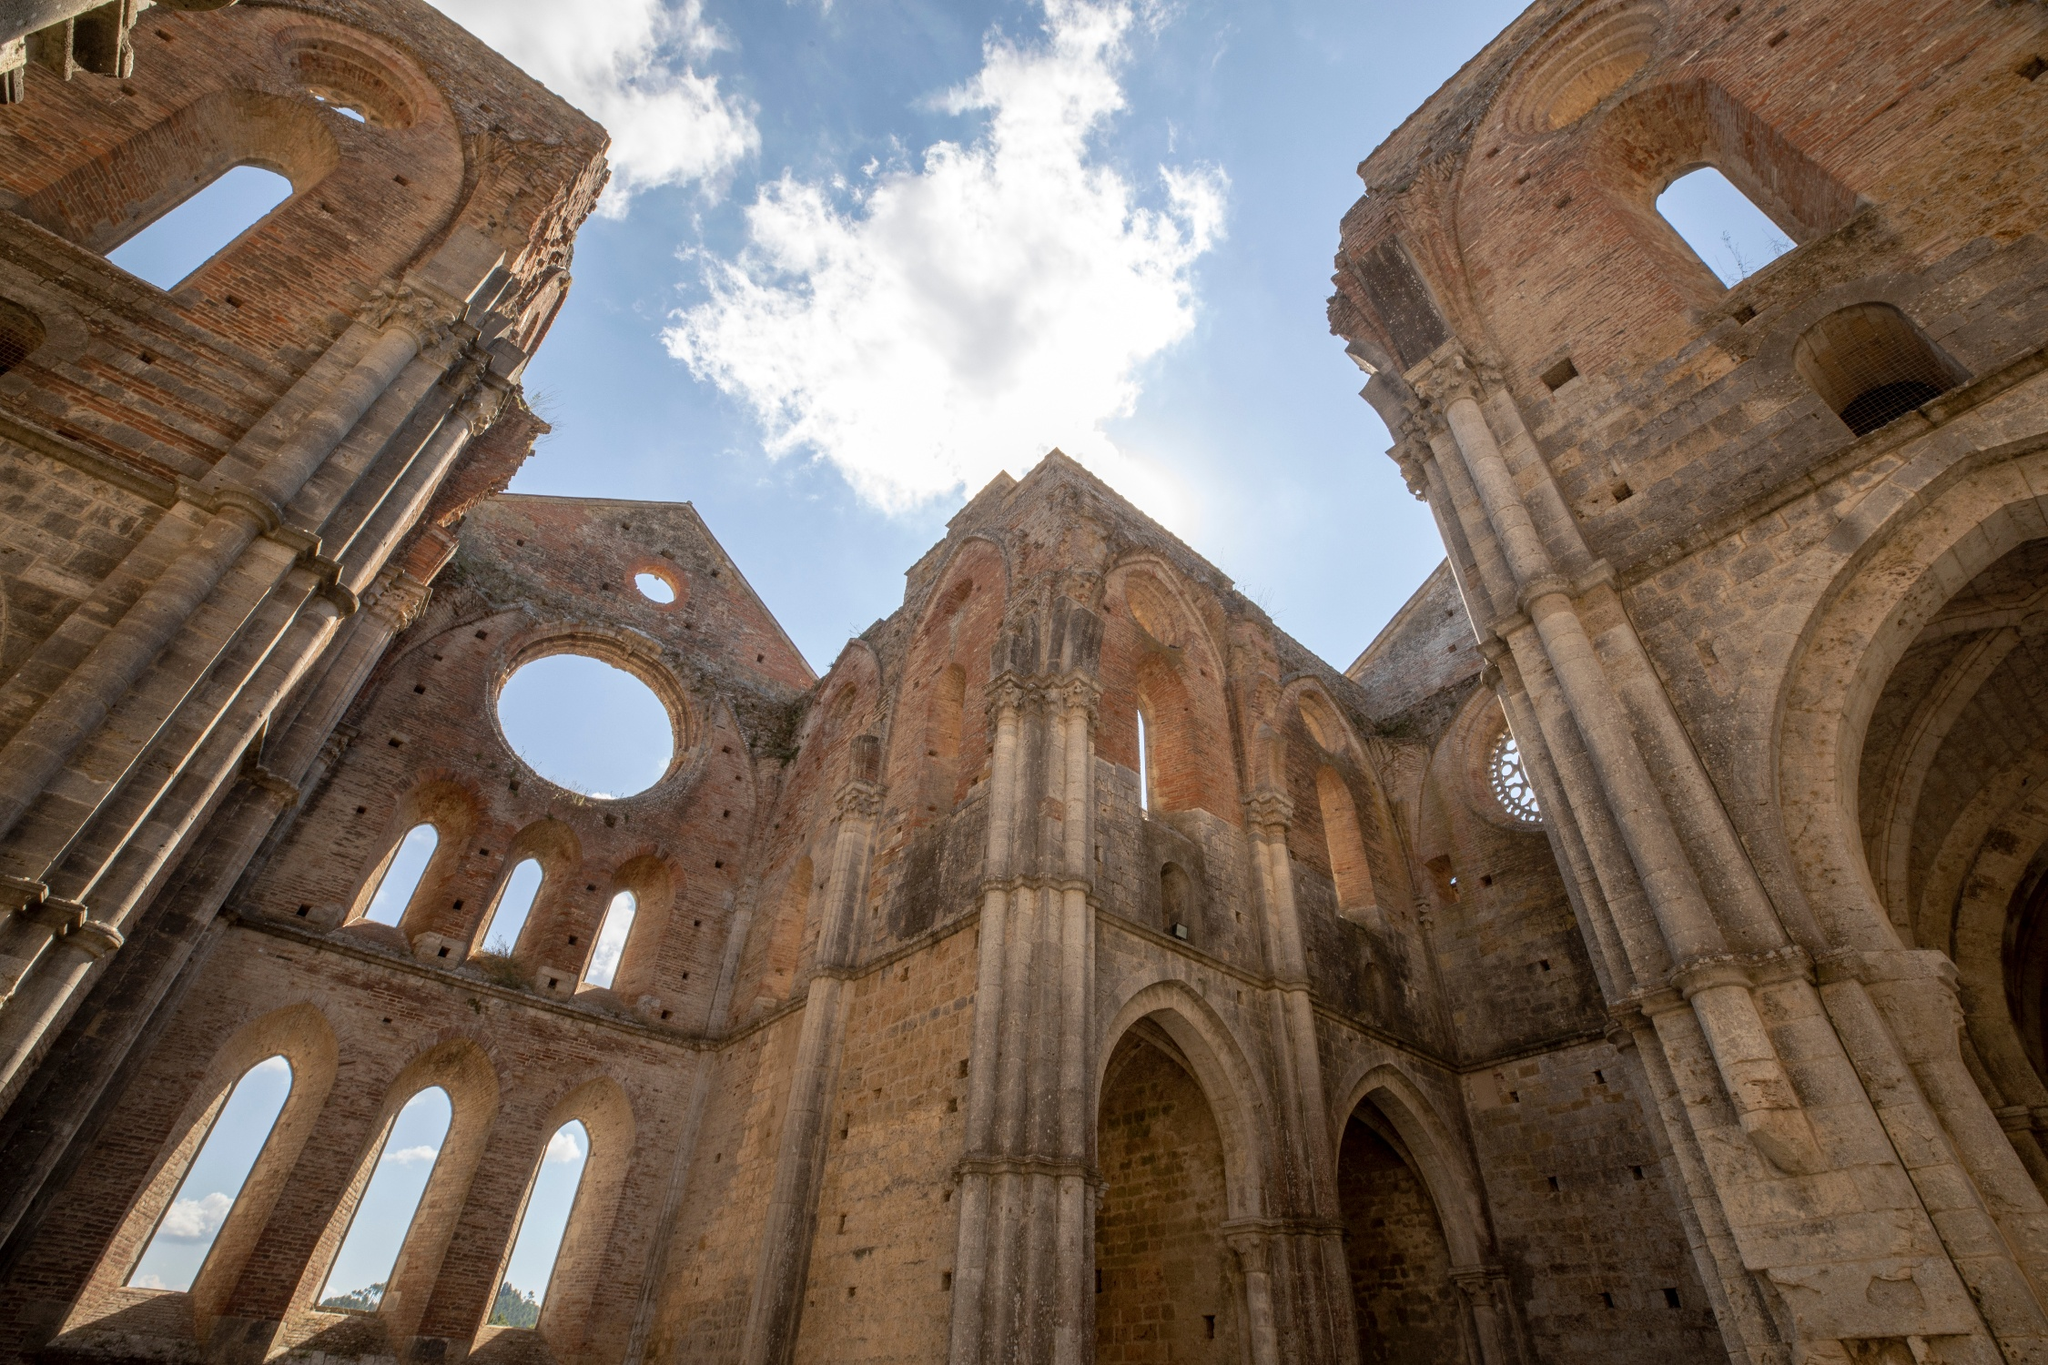If these ruins could talk, what stories would they tell? If the ancient stones of these ruins could talk, they would recount tales of reverence and ruin, of hopes and heartaches that have touched their towering arches. They would speak of the countless souls who once gathered within these now-empty halls, their prayers and hymns echoing through the centuries. They would remember the grand processions and solemn vows taken at the altar, now crumbled and quiet. They would tell of the great storm that brought down the mighty roof, and the wars that saw these walls witness both refuge and destruction.

The stones would reminisce about the artisans who, with delicate hands, etched their undying faith into every intricate carving and the villagers who sought solace within these walls during turbulent times. They would recount the whispers of lovers who stole secret moments away from prying eyes, and the innocent laughter of children, now long grown and gone.

These ruins, once the heart of a thriving community, now stand as a silent testament to resilience. They hold the echoes of the past, a reminder of the human spirit’s enduring strength and the relentless march of time that spares nothing in its path. Consider a post-apocalyptic future where these ruins are rediscovered. Write a short story about that. In the year 3025, Earth was a vastly different place, a planet slowly healing from centuries of human folly. Nature had reclaimed vast stretches of the old world, and new societies were forming, grounded in harmony and respect for the planet. Amidst this transformation, a small expedition group stumbled upon the forgotten ruins of an ancient cathedral, hidden deep within an overgrown forest.

The group, led by Lyra, an intrepid archaeologist, and her team of historians, approached the imposing arches with a mix of awe and reverence. The ruins, though weathered and partially crumbled, exuded an undeniable grandeur that transcended the ages. Vines and moss had weaved a verdant tapestry over the stone, and the open sky above created a natural dome that framed the remnants in a surreal light.

As they carefully navigated the sacred grounds, they found relics of a bygone era—tattered books of sacred texts, shattered stained glass with vibrant hues still visible, and stone engravings narrating tales of faith and perseverance. Lyra's heart raced as she uncovered a hidden chamber beneath the altar, untouched and waiting to share its secrets.

Inside the chamber, the group found a time capsule left by the ancient inhabitants. It contained artifacts of their daily life: a child's toy, a hand-written journal, and a small, well-preserved locket with a portrait of a woman and a man, likely once lost lovers separated by fate. The discovery stirred emotions among the group, a poignant reminder of the shared humanity that connected their distant past with their present.

Lyra and her team documented every find, knowing that these ruins held invaluable lessons. They resolved to preserve and protect this sacred site, ensuring that future generations could learn from the resilience and faith that had once defined these walls. As they departed, the cathedral’s stones basked in the warm glow of the setting sun, silently promising to hold their new stories for centuries to come. Can you hypothesize a realistic historical narrative for these ruins? Based on the architectural style and the materials used in the construction of these ruins, it is plausible to hypothesize that this was once a grand Gothic cathedral, constructed during the High Middle Ages, around the 12th to 14th centuries. The expansive arches, ribbed vaults, and pointed windows suggest a design meant to inspire awe and direct the gaze heavenwards, characteristic of Gothic architecture.

Historically, such cathedrals were central to both the religious and social lives of their communities. This cathedral likely served as a seat of the local bishopric, a place where significant religious ceremonies and events took place. It might have witnessed countless baptisms, weddings, and funerals, each leaving behind a trace of its human tapestry.

Its grand scale implies that it was a major pilgrimage site, drawing the faithful from surrounding regions. The rich histories etched into its walls suggest that skilled artisans spent decades embellishing the cathedral with elaborate stone carvings, stained glass windows depicting biblical scenes, and frescoes narrating the saints' lives.

The passage of time and the advent of wars, possibly the turbulence of the Reformation or local conflicts, could have led to its partial destruction. Natural disasters, such as earthquakes or fires, might also have contributed to its current state of disrepair. Over the centuries, as communities moved and the function of the cathedral diminished, it gradually fell into ruin, becoming the hauntingly beautiful relic we see today. How would nature interact with these ruins over time? Over time, nature would have a profound impact on the enduring ruins of the ancient cathedral, transforming the site into a symbiotic blend of human history and the natural world. Rain, wind, and varying temperatures would slowly erode the stonework, softening the once sharp edges and leading to the gradual disintegration of more delicate architectural features. Moss and lichen would take root in the damp crevices, spreading across the surfaces and adding a green patina to the weathered stone.

Climbing plants like ivy would envelop the columns and arches, their tendrils weaving through cracks and crevices, both stabilizing and further fracturing the structure. In time, entire sections might become cloaked in verdant foliage, lending the ruins a sense of timelessness and ethereal beauty.

Trees might sprout in the abandoned chambers and courtyards, their roots burrowing deep into the earth and the structure itself, hastening the breakdown of stonework but also adding a surreal, forested aspect to the ruins. Birdsong and the rustle of small animals would become a constant presence, as the ruins transform into a thriving ecosystem.

Through this interaction, the ruins would continue to evolve, their human-made forms gracefully yielding to the persistent, slow embrace of nature, creating a captivating narrative of time and transformation for future generations to discover and admire. 